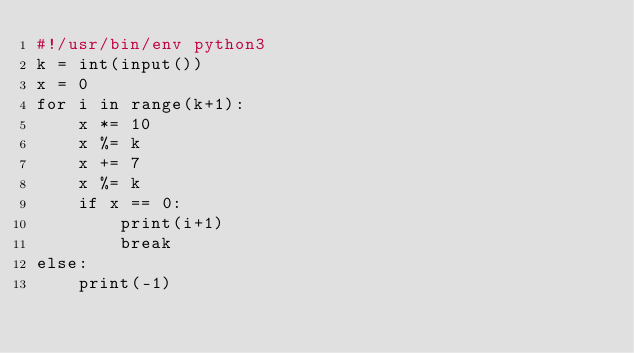Convert code to text. <code><loc_0><loc_0><loc_500><loc_500><_Python_>#!/usr/bin/env python3
k = int(input())
x = 0
for i in range(k+1):
    x *= 10
    x %= k
    x += 7
    x %= k
    if x == 0:
        print(i+1)
        break
else:
    print(-1)</code> 